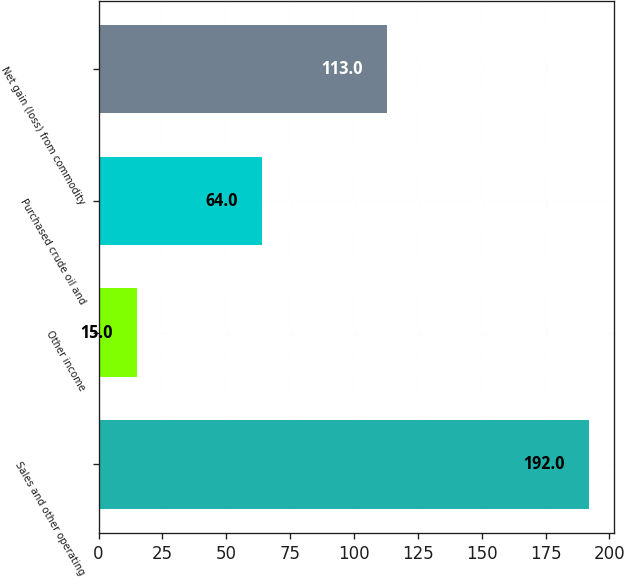Convert chart. <chart><loc_0><loc_0><loc_500><loc_500><bar_chart><fcel>Sales and other operating<fcel>Other income<fcel>Purchased crude oil and<fcel>Net gain (loss) from commodity<nl><fcel>192<fcel>15<fcel>64<fcel>113<nl></chart> 